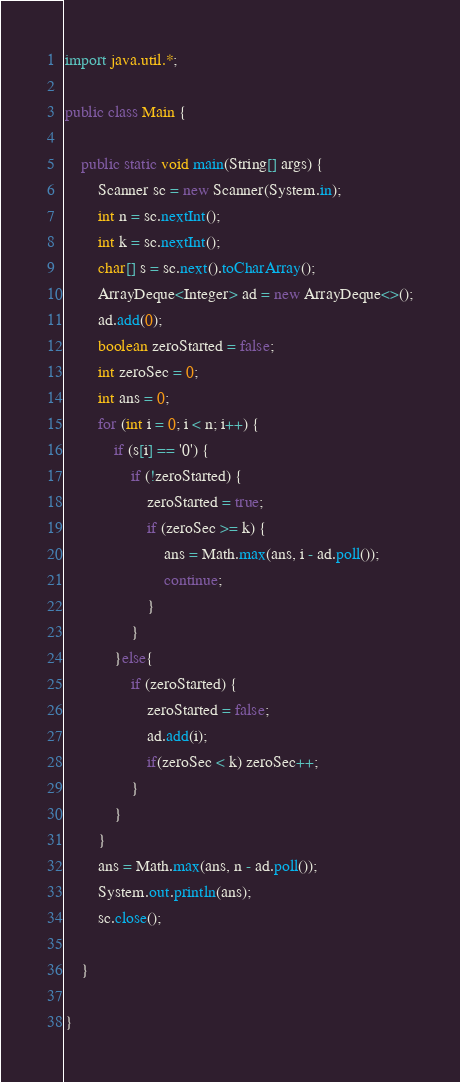Convert code to text. <code><loc_0><loc_0><loc_500><loc_500><_Java_>import java.util.*;

public class Main {

    public static void main(String[] args) {
        Scanner sc = new Scanner(System.in);
        int n = sc.nextInt();
        int k = sc.nextInt();
        char[] s = sc.next().toCharArray();
        ArrayDeque<Integer> ad = new ArrayDeque<>();
        ad.add(0);
        boolean zeroStarted = false;
        int zeroSec = 0;
        int ans = 0;
        for (int i = 0; i < n; i++) {
            if (s[i] == '0') {
                if (!zeroStarted) {
                    zeroStarted = true;
                    if (zeroSec >= k) {
                        ans = Math.max(ans, i - ad.poll());
                        continue;
                    }
                }
            }else{
                if (zeroStarted) {
                    zeroStarted = false;
                    ad.add(i);
                    if(zeroSec < k) zeroSec++;
                }
            }
        }
        ans = Math.max(ans, n - ad.poll());
        System.out.println(ans);
        sc.close();

    }

}
</code> 